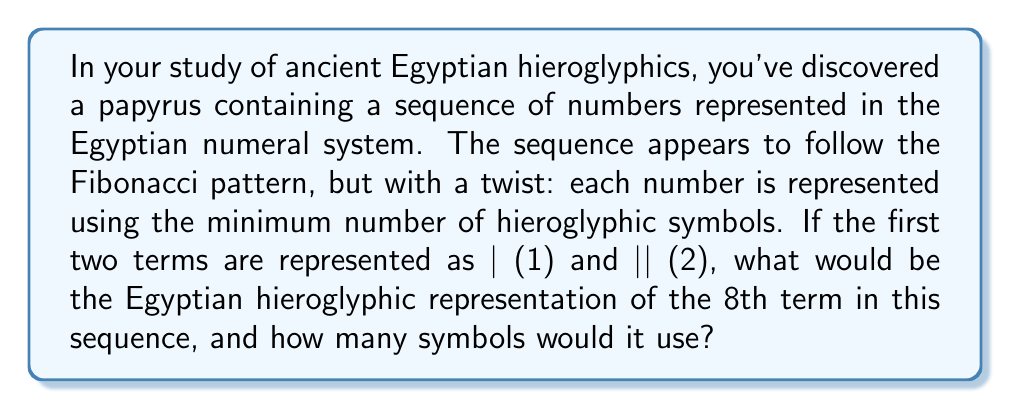Show me your answer to this math problem. To solve this problem, we need to follow these steps:

1. Generate the Fibonacci sequence up to the 8th term:
   $$F_n = F_{n-1} + F_{n-2}$$
   $F_1 = 1$, $F_2 = 2$
   $F_3 = 1 + 2 = 3$
   $F_4 = 2 + 3 = 5$
   $F_5 = 3 + 5 = 8$
   $F_6 = 5 + 8 = 13$
   $F_7 = 8 + 13 = 21$
   $F_8 = 13 + 21 = 34$

2. Understand the Egyptian numeral system:
   | = 1
   ∩ = 10
   ☾ = 100
   ♈︎ = 1000

3. Represent 34 using the minimum number of hieroglyphic symbols:
   34 = 3 * 10 + 4 * 1
   In hieroglyphics: ∩∩∩||||

4. Count the number of symbols used:
   3 tens (∩) + 4 ones (|) = 7 symbols total

Therefore, the 8th term of the sequence (34) would be represented as ∩∩∩|||| in Egyptian hieroglyphics, using 7 symbols.
Answer: ∩∩∩||||, 7 symbols 